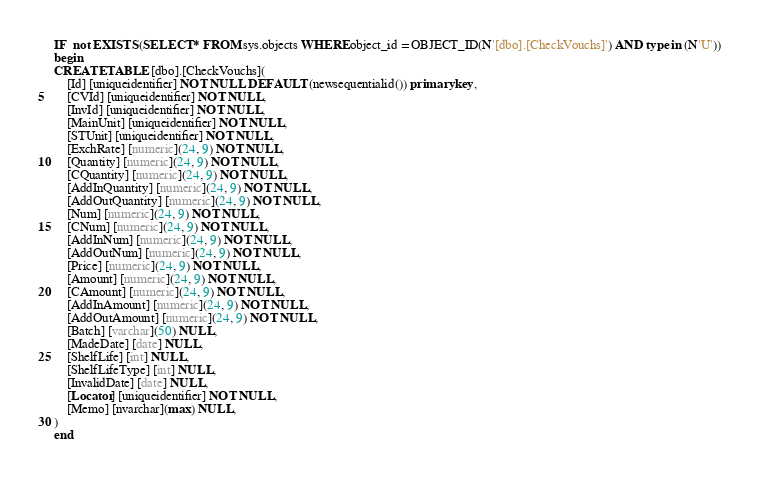Convert code to text. <code><loc_0><loc_0><loc_500><loc_500><_SQL_>IF  not EXISTS (SELECT * FROM sys.objects WHERE object_id = OBJECT_ID(N'[dbo].[CheckVouchs]') AND type in (N'U'))
begin
CREATE TABLE [dbo].[CheckVouchs](
	[Id] [uniqueidentifier] NOT NULL DEFAULT (newsequentialid()) primary key,
	[CVId] [uniqueidentifier] NOT NULL,
	[InvId] [uniqueidentifier] NOT NULL,
	[MainUnit] [uniqueidentifier] NOT NULL,
	[STUnit] [uniqueidentifier] NOT NULL,
	[ExchRate] [numeric](24, 9) NOT NULL,
	[Quantity] [numeric](24, 9) NOT NULL,
	[CQuantity] [numeric](24, 9) NOT NULL,
	[AddInQuantity] [numeric](24, 9) NOT NULL,
	[AddOutQuantity] [numeric](24, 9) NOT NULL,
	[Num] [numeric](24, 9) NOT NULL,
	[CNum] [numeric](24, 9) NOT NULL,
	[AddInNum] [numeric](24, 9) NOT NULL,
	[AddOutNum] [numeric](24, 9) NOT NULL,
	[Price] [numeric](24, 9) NOT NULL,
	[Amount] [numeric](24, 9) NOT NULL,
	[CAmount] [numeric](24, 9) NOT NULL,
	[AddInAmount] [numeric](24, 9) NOT NULL,
	[AddOutAmount] [numeric](24, 9) NOT NULL,
	[Batch] [varchar](50) NULL,
	[MadeDate] [date] NULL,
	[ShelfLife] [int] NULL,
	[ShelfLifeType] [int] NULL,
	[InvalidDate] [date] NULL,
	[Locator] [uniqueidentifier] NOT NULL,
	[Memo] [nvarchar](max) NULL,
)
end

</code> 